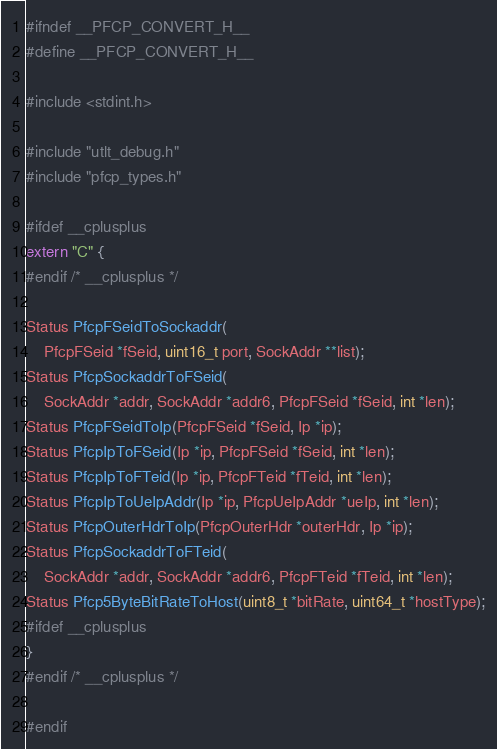<code> <loc_0><loc_0><loc_500><loc_500><_C_>#ifndef __PFCP_CONVERT_H__
#define __PFCP_CONVERT_H__

#include <stdint.h>

#include "utlt_debug.h"
#include "pfcp_types.h"

#ifdef __cplusplus
extern "C" {
#endif /* __cplusplus */

Status PfcpFSeidToSockaddr(
    PfcpFSeid *fSeid, uint16_t port, SockAddr **list);
Status PfcpSockaddrToFSeid(
    SockAddr *addr, SockAddr *addr6, PfcpFSeid *fSeid, int *len);
Status PfcpFSeidToIp(PfcpFSeid *fSeid, Ip *ip);
Status PfcpIpToFSeid(Ip *ip, PfcpFSeid *fSeid, int *len);
Status PfcpIpToFTeid(Ip *ip, PfcpFTeid *fTeid, int *len);
Status PfcpIpToUeIpAddr(Ip *ip, PfcpUeIpAddr *ueIp, int *len);
Status PfcpOuterHdrToIp(PfcpOuterHdr *outerHdr, Ip *ip);
Status PfcpSockaddrToFTeid(
    SockAddr *addr, SockAddr *addr6, PfcpFTeid *fTeid, int *len);
Status Pfcp5ByteBitRateToHost(uint8_t *bitRate, uint64_t *hostType);
#ifdef __cplusplus
}
#endif /* __cplusplus */

#endif
</code> 